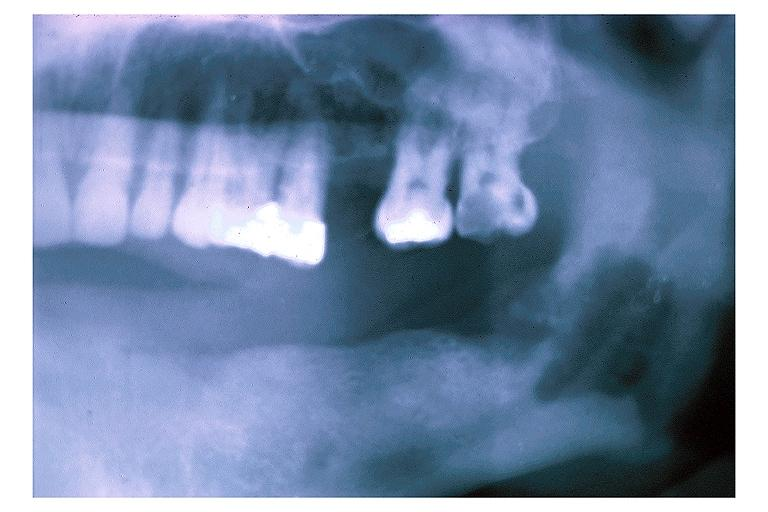does this image show chronic osteomyelitis?
Answer the question using a single word or phrase. Yes 